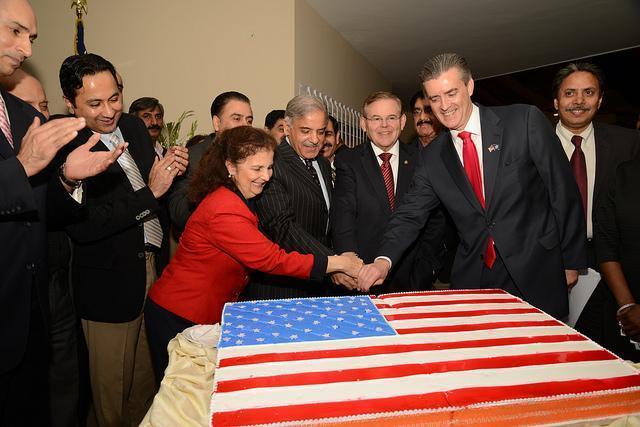How many people are wearing orange sweaters?
Give a very brief answer. 0. How many people are there?
Give a very brief answer. 8. How many zebras are in the image?
Give a very brief answer. 0. 